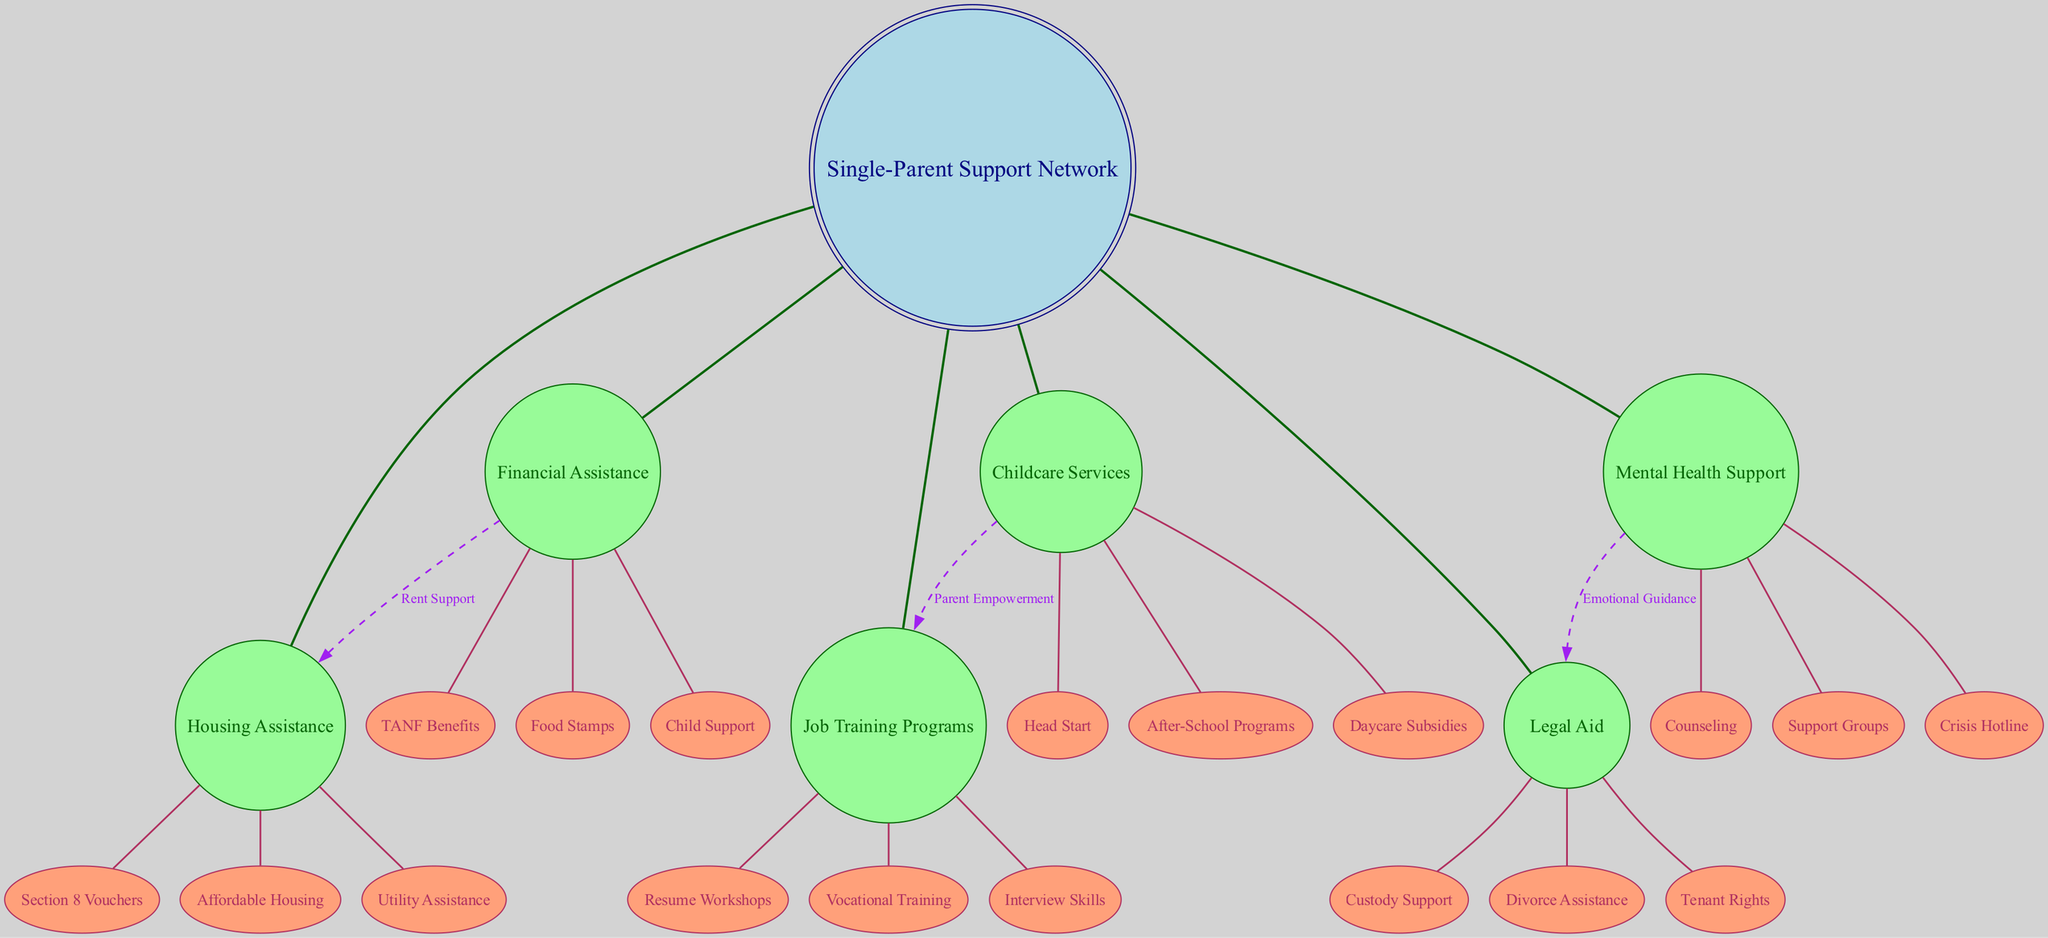What is the central node of the diagram? The central node is marked clearly and represents the focal point of the diagram. In this case, it relates to the Single-Parent Support Network.
Answer: Single-Parent Support Network How many orbiting bodies are there? By counting the bodies surrounding the central node, we see there are six distinct orbiting bodies listed in the diagram.
Answer: 6 What type of connections exist between Financial Assistance and Housing Assistance? The connection is labeled and shows a direct relationship indicating support for rent between these two resources in the diagram.
Answer: Rent Support Which orbiting body connects to Job Training Programs? The orbiting body that connects to Job Training Programs is Childcare Services, as shown by an empowerment relationship in the diagram.
Answer: Childcare Services What type of support does Mental Health Support provide to Legal Aid? The connection indicates a form of guidance where Mental Health Support provides emotional support to Legal Aid, as visually indicated in the diagram.
Answer: Emotional Guidance How many satellite nodes are connected to Financial Assistance? Upon examining the satellites under Financial Assistance, there are three nodes that fall under this category, which represent various types of assistance.
Answer: 3 Which service is linked to both Housing Assistance and Financial Assistance? Housing Assistance is explicitly connected to Financial Assistance through the Rent Support label, establishing a direct link shown in the diagram.
Answer: Housing Assistance What are three types of assistance provided under Childcare Services? The Childcare Services include three specific programs identified in the diagram: Head Start, After-School Programs, and Daycare Subsidies.
Answer: Head Start, After-School Programs, Daycare Subsidies Which type of assistance does Job Training Programs support? The diagram indicates that Job Training Programs support employment-related skills development, specifically linked to services that empower parents.
Answer: Parent Empowerment 